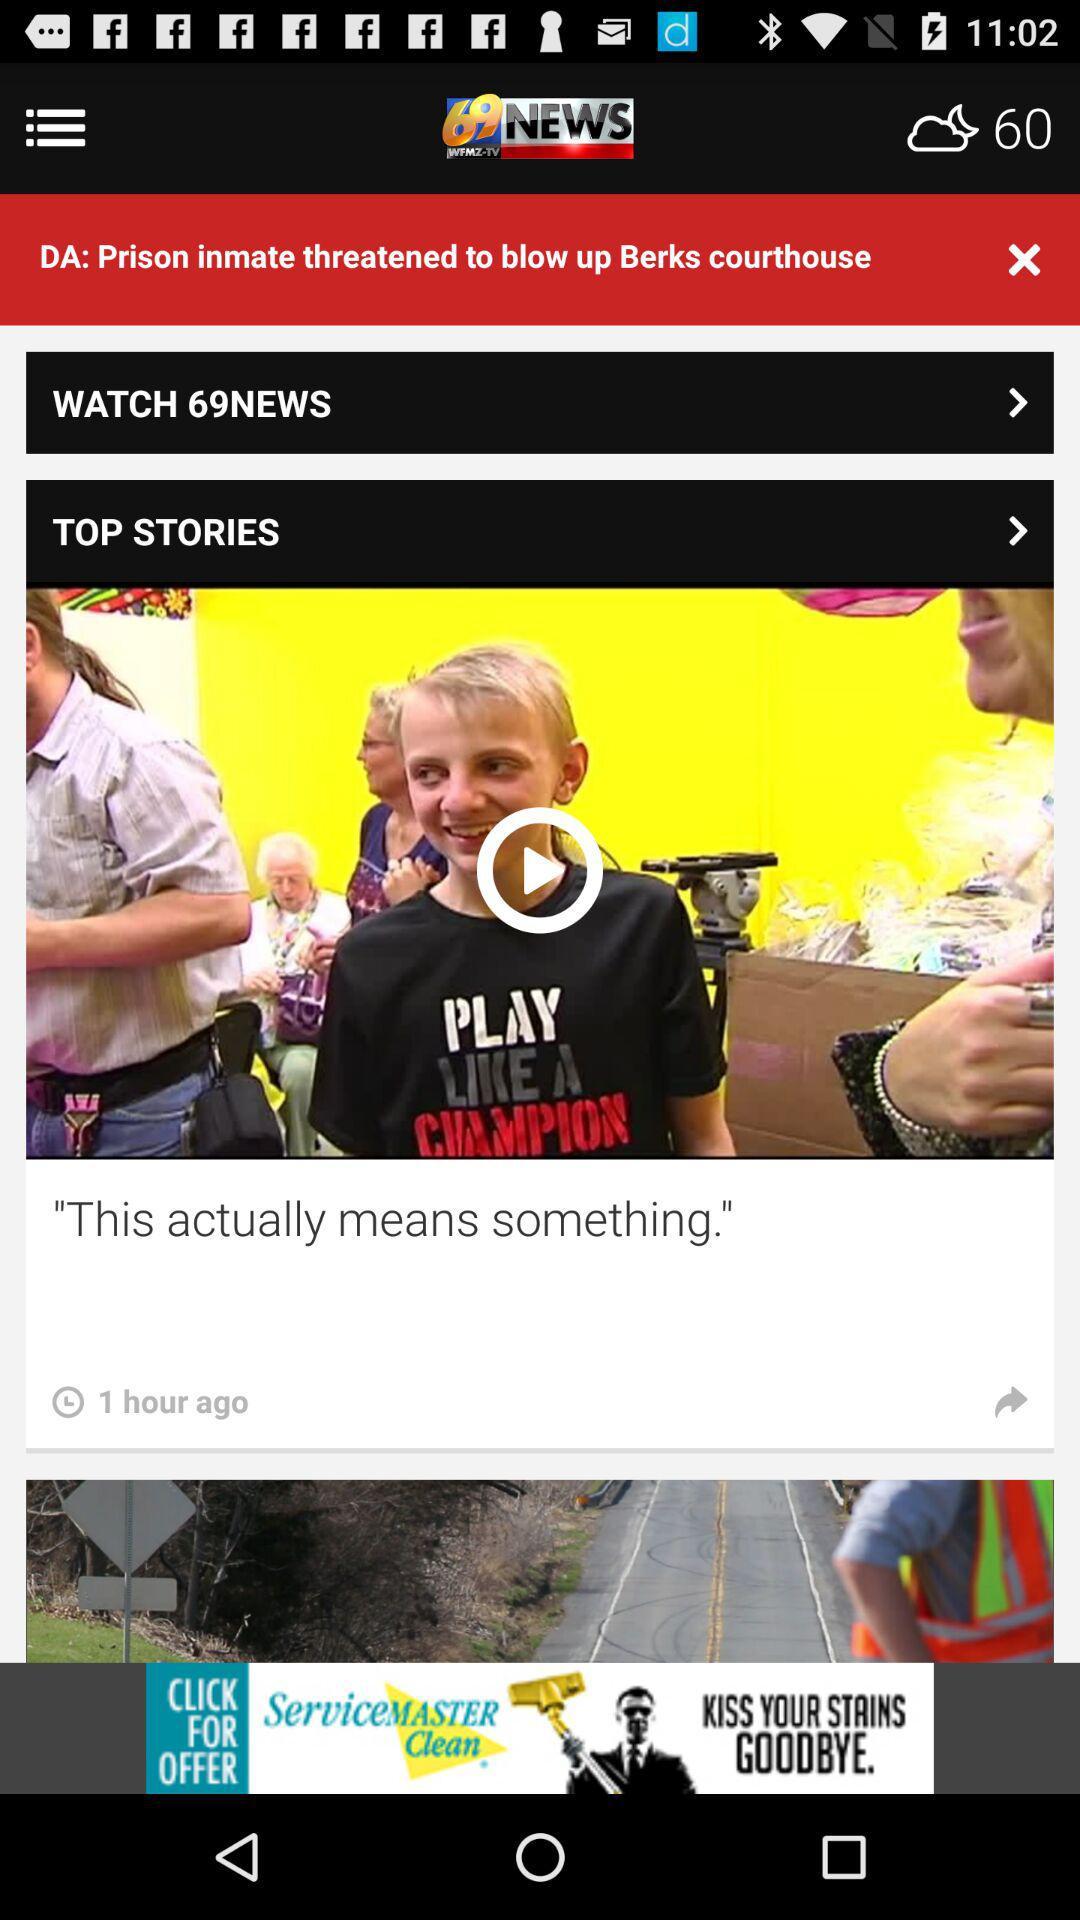What's the temperature? The temperature is 60. 